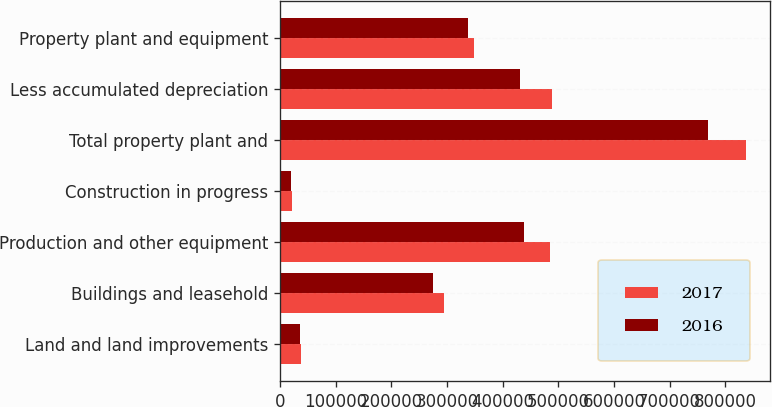Convert chart to OTSL. <chart><loc_0><loc_0><loc_500><loc_500><stacked_bar_chart><ecel><fcel>Land and land improvements<fcel>Buildings and leasehold<fcel>Production and other equipment<fcel>Construction in progress<fcel>Total property plant and<fcel>Less accumulated depreciation<fcel>Property plant and equipment<nl><fcel>2017<fcel>37525<fcel>294219<fcel>484475<fcel>22140<fcel>838359<fcel>489081<fcel>349278<nl><fcel>2016<fcel>35720<fcel>274021<fcel>438604<fcel>20204<fcel>768549<fcel>431431<fcel>337118<nl></chart> 